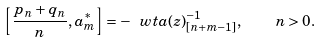Convert formula to latex. <formula><loc_0><loc_0><loc_500><loc_500>\left [ \frac { p _ { n } + q _ { n } } { n } , a ^ { * } _ { m } \right ] = - \ w t { a } ( z ) ^ { - 1 } _ { [ n + m - 1 ] } , \quad n > 0 .</formula> 